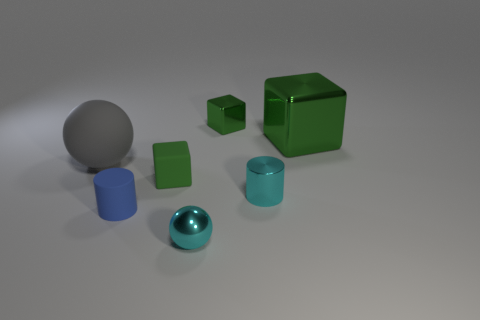Subtract all green blocks. How many were subtracted if there are1green blocks left? 2 Subtract all small blocks. How many blocks are left? 1 Add 3 big green cubes. How many objects exist? 10 Subtract all gray blocks. Subtract all gray spheres. How many blocks are left? 3 Subtract all cubes. How many objects are left? 4 Add 7 large metallic cubes. How many large metallic cubes exist? 8 Subtract 0 brown spheres. How many objects are left? 7 Subtract all big metal objects. Subtract all yellow cylinders. How many objects are left? 6 Add 5 tiny metallic cubes. How many tiny metallic cubes are left? 6 